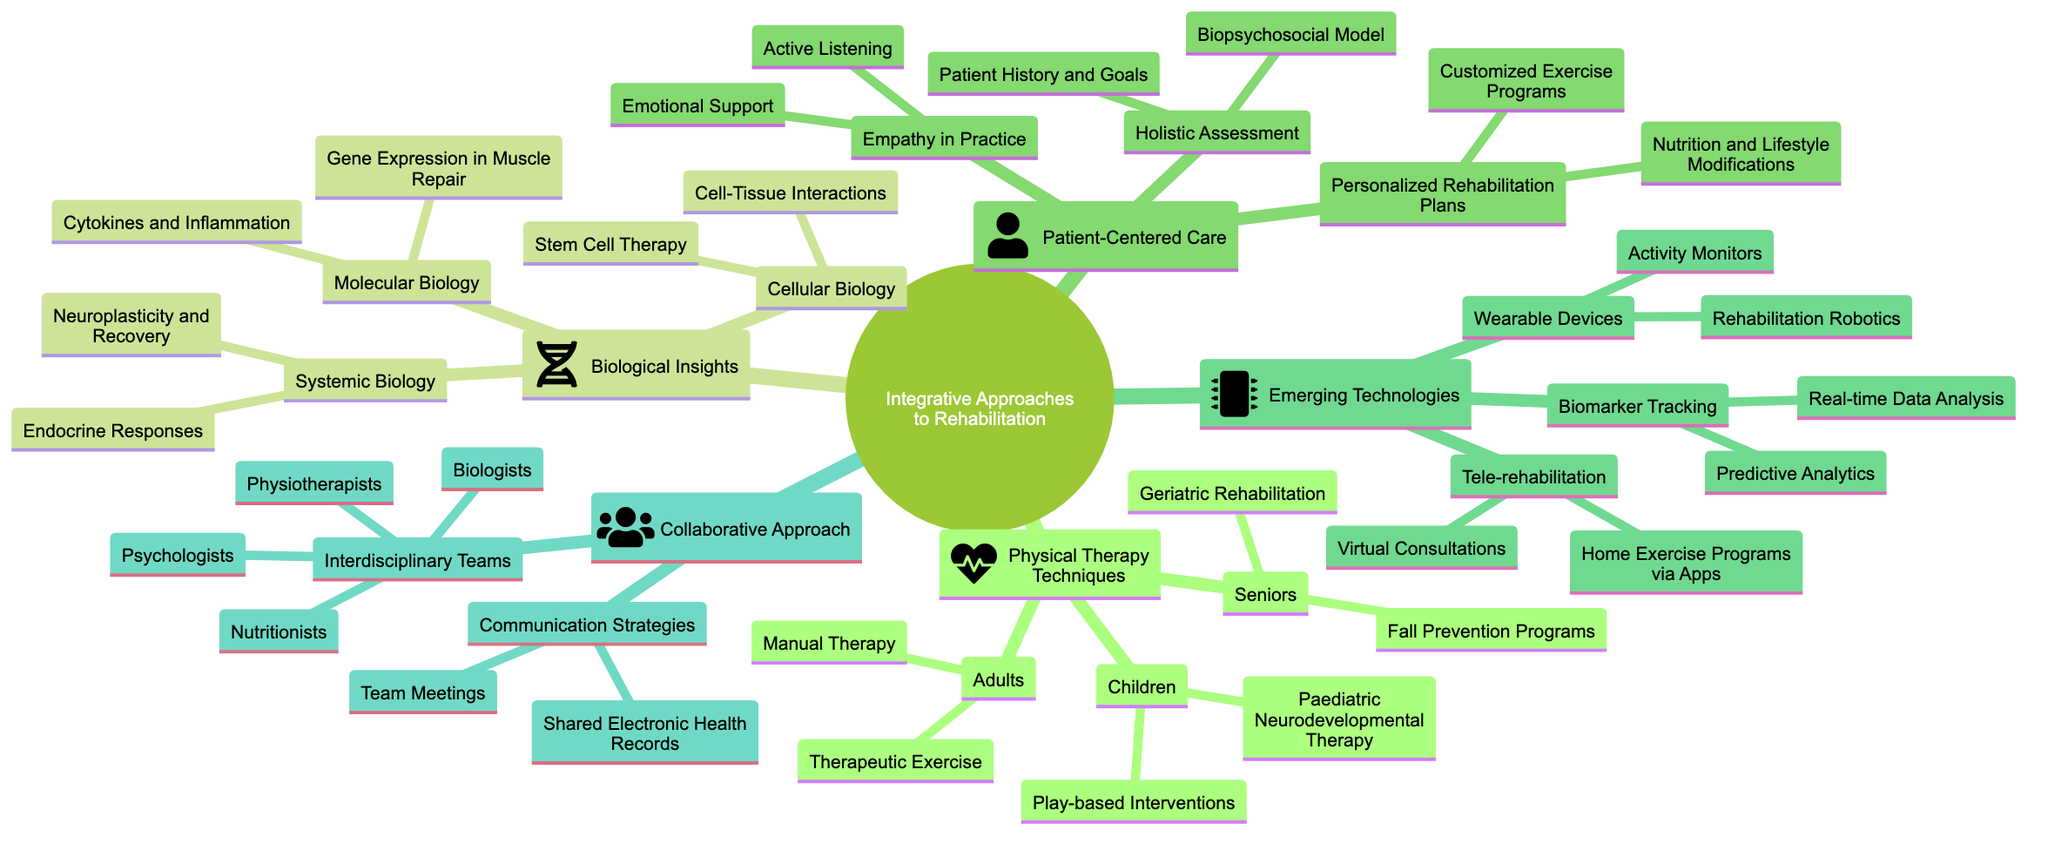What are the three main branches of the diagram? The three main branches directly connected to the central node "Integrative Approaches to Rehabilitation" are "Physical Therapy Techniques," "Biological Insights," and "Patient-Centered Care."
Answer: Physical Therapy Techniques, Biological Insights, Patient-Centered Care How many techniques are listed under "Physical Therapy Techniques"? There are three categories under "Physical Therapy Techniques": "Children," "Adults," and "Seniors." Each category lists two specific techniques, totaling six techniques overall.
Answer: Six What type of biological insights does the diagram include under "Cellular Biology"? Under "Cellular Biology," the diagram specifies "Stem Cell Therapy" and "Cell-Tissue Interactions" as the insights included in this section.
Answer: Stem Cell Therapy and Cell-Tissue Interactions Which technology category includes "Virtual Consultations"? "Virtual Consultations" falls under the "Tele-rehabilitation" category, which is a part of the "Emerging Technologies" main branch.
Answer: Tele-rehabilitation How is empathy represented in the patient-centered care section? In the "Patient-Centered Care" section, "Empathy in Practice" is explicitly mentioned with two sub-categories: "Active Listening" and "Emotional Support."
Answer: Active Listening and Emotional Support What interdisciplinary professionals are included in the "Collaborative Approach"? The "Collaborative Approach" includes physiotherapists, biologists, psychologists, and nutritionists as interdisciplinary professionals.
Answer: Physiotherapists, biologists, psychologists, nutritionists How does systemic biology contribute to rehabilitation according to the diagram? In the "Systemic Biology" category, the contributions to rehabilitation are described as "Endocrine Responses" and "Neuroplasticity and Recovery," indicating both physiological and neurological aspects.
Answer: Endocrine Responses and Neuroplasticity and Recovery What type of devices are categorized under “Wearable Devices”? The "Wearable Devices" category includes "Activity Monitors" and "Rehabilitation Robotics," suggesting tools for monitoring and assisting in rehabilitation.
Answer: Activity Monitors and Rehabilitation Robotics What is the main purpose of "Personalized Rehabilitation Plans"? The main purpose of "Personalized Rehabilitation Plans" is to create tailored programs that consider individual needs, focusing on "Customized Exercise Programs" and "Nutrition and Lifestyle Modifications."
Answer: Tailored programs 